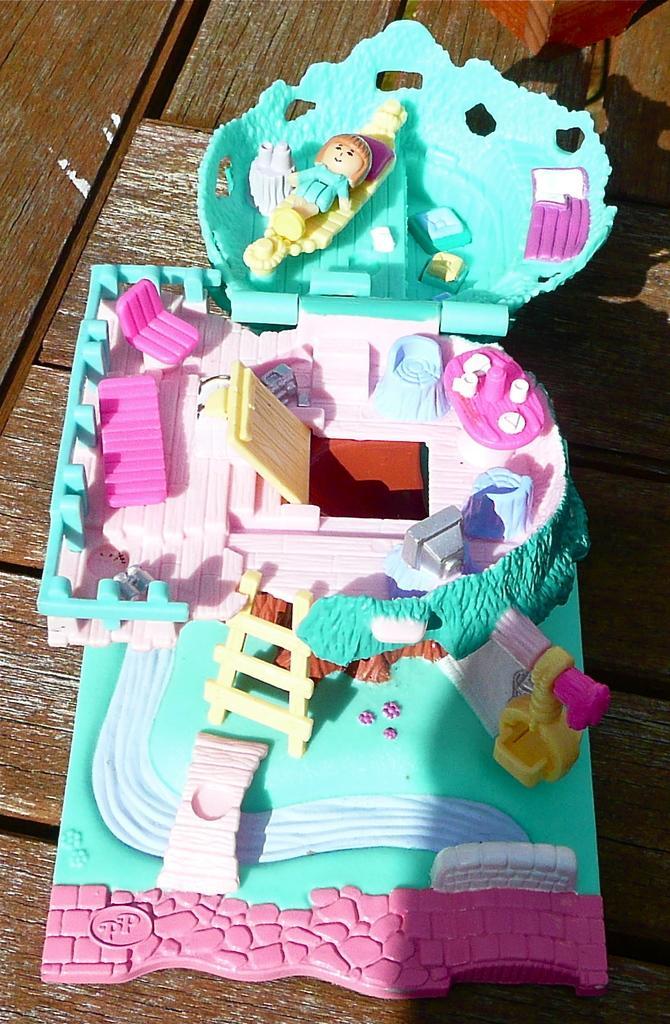Please provide a concise description of this image. This image consists of a miniature is kept on the floor made up of wood. 